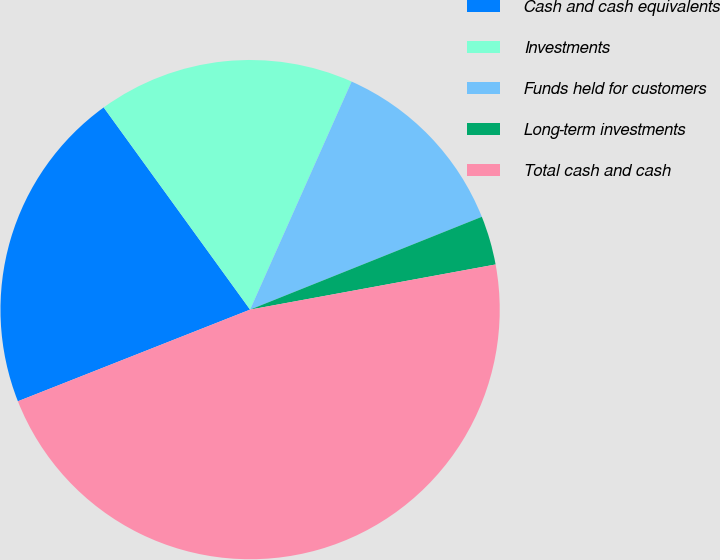<chart> <loc_0><loc_0><loc_500><loc_500><pie_chart><fcel>Cash and cash equivalents<fcel>Investments<fcel>Funds held for customers<fcel>Long-term investments<fcel>Total cash and cash<nl><fcel>21.01%<fcel>16.64%<fcel>12.27%<fcel>3.17%<fcel>46.91%<nl></chart> 